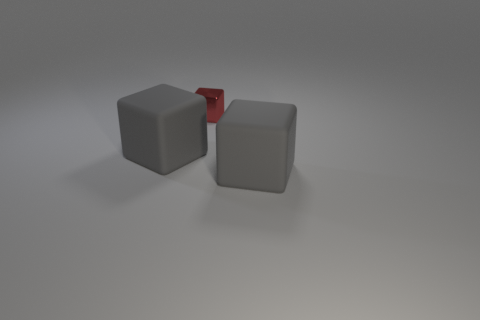Is there anything else that is the same size as the metallic object?
Give a very brief answer. No. Is there any other thing that is made of the same material as the small red object?
Ensure brevity in your answer.  No. Are there more things in front of the tiny red cube than small blue cylinders?
Ensure brevity in your answer.  Yes. How many objects are either tiny red metallic cubes or large gray matte objects right of the red cube?
Offer a very short reply. 2. The red thing that is behind the large gray rubber cube that is on the right side of the matte thing that is left of the tiny shiny cube is made of what material?
Make the answer very short. Metal. There is a gray matte cube left of the tiny shiny thing; are there any small red cubes behind it?
Offer a terse response. Yes. The red cube has what size?
Your answer should be very brief. Small. What number of objects are large cubes or big green rubber cylinders?
Provide a short and direct response. 2. Are the gray block on the left side of the red block and the gray object to the right of the tiny cube made of the same material?
Provide a short and direct response. Yes. How many gray rubber things are the same size as the red thing?
Your answer should be very brief. 0. 